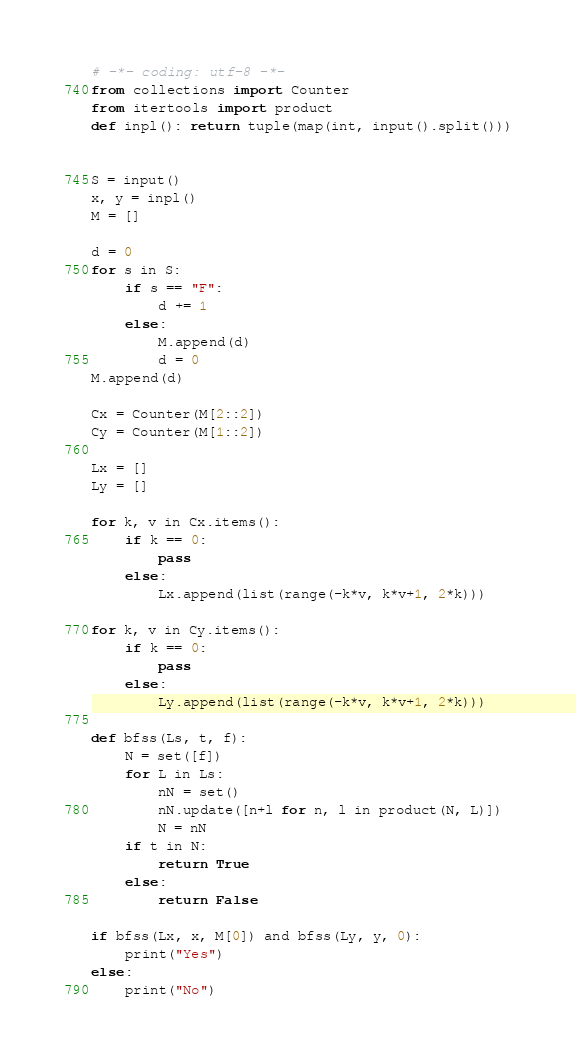<code> <loc_0><loc_0><loc_500><loc_500><_Python_># -*- coding: utf-8 -*-
from collections import Counter
from itertools import product
def inpl(): return tuple(map(int, input().split()))
   

S = input()
x, y = inpl()
M = []

d = 0
for s in S:
    if s == "F":
        d += 1
    else:
        M.append(d)
        d = 0
M.append(d)

Cx = Counter(M[2::2])
Cy = Counter(M[1::2])

Lx = []
Ly = []

for k, v in Cx.items():
    if k == 0:
        pass
    else:
        Lx.append(list(range(-k*v, k*v+1, 2*k)))
        
for k, v in Cy.items():
    if k == 0:
        pass
    else:
        Ly.append(list(range(-k*v, k*v+1, 2*k)))

def bfss(Ls, t, f):
    N = set([f])
    for L in Ls:
        nN = set()
        nN.update([n+l for n, l in product(N, L)])
        N = nN
    if t in N:
        return True
    else:
        return False

if bfss(Lx, x, M[0]) and bfss(Ly, y, 0):
    print("Yes")
else:
    print("No")</code> 